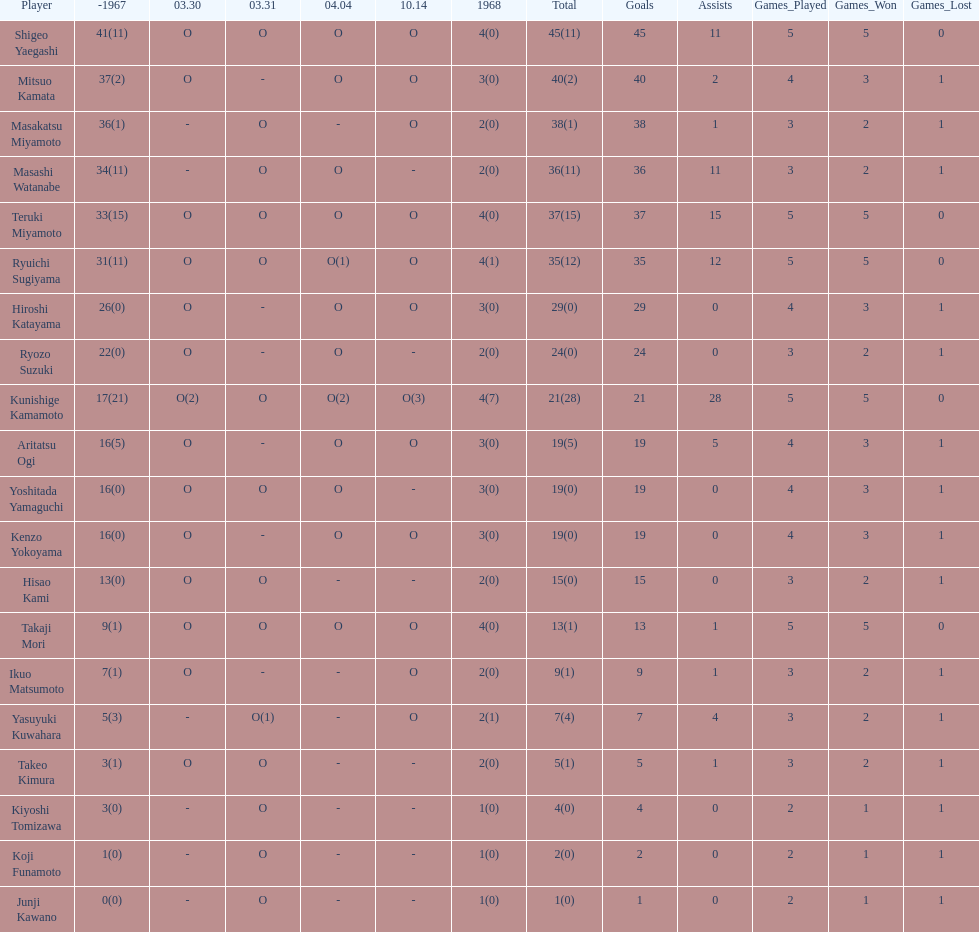Who are all of the players? Shigeo Yaegashi, Mitsuo Kamata, Masakatsu Miyamoto, Masashi Watanabe, Teruki Miyamoto, Ryuichi Sugiyama, Hiroshi Katayama, Ryozo Suzuki, Kunishige Kamamoto, Aritatsu Ogi, Yoshitada Yamaguchi, Kenzo Yokoyama, Hisao Kami, Takaji Mori, Ikuo Matsumoto, Yasuyuki Kuwahara, Takeo Kimura, Kiyoshi Tomizawa, Koji Funamoto, Junji Kawano. How many points did they receive? 45(11), 40(2), 38(1), 36(11), 37(15), 35(12), 29(0), 24(0), 21(28), 19(5), 19(0), 19(0), 15(0), 13(1), 9(1), 7(4), 5(1), 4(0), 2(0), 1(0). What about just takaji mori and junji kawano? 13(1), 1(0). Of the two, who had more points? Takaji Mori. 